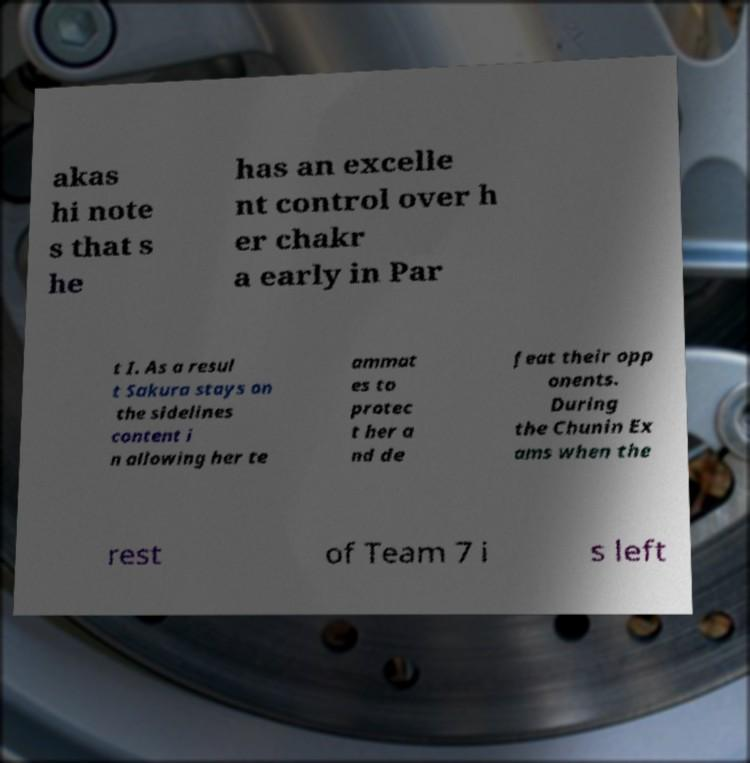Please identify and transcribe the text found in this image. akas hi note s that s he has an excelle nt control over h er chakr a early in Par t I. As a resul t Sakura stays on the sidelines content i n allowing her te ammat es to protec t her a nd de feat their opp onents. During the Chunin Ex ams when the rest of Team 7 i s left 